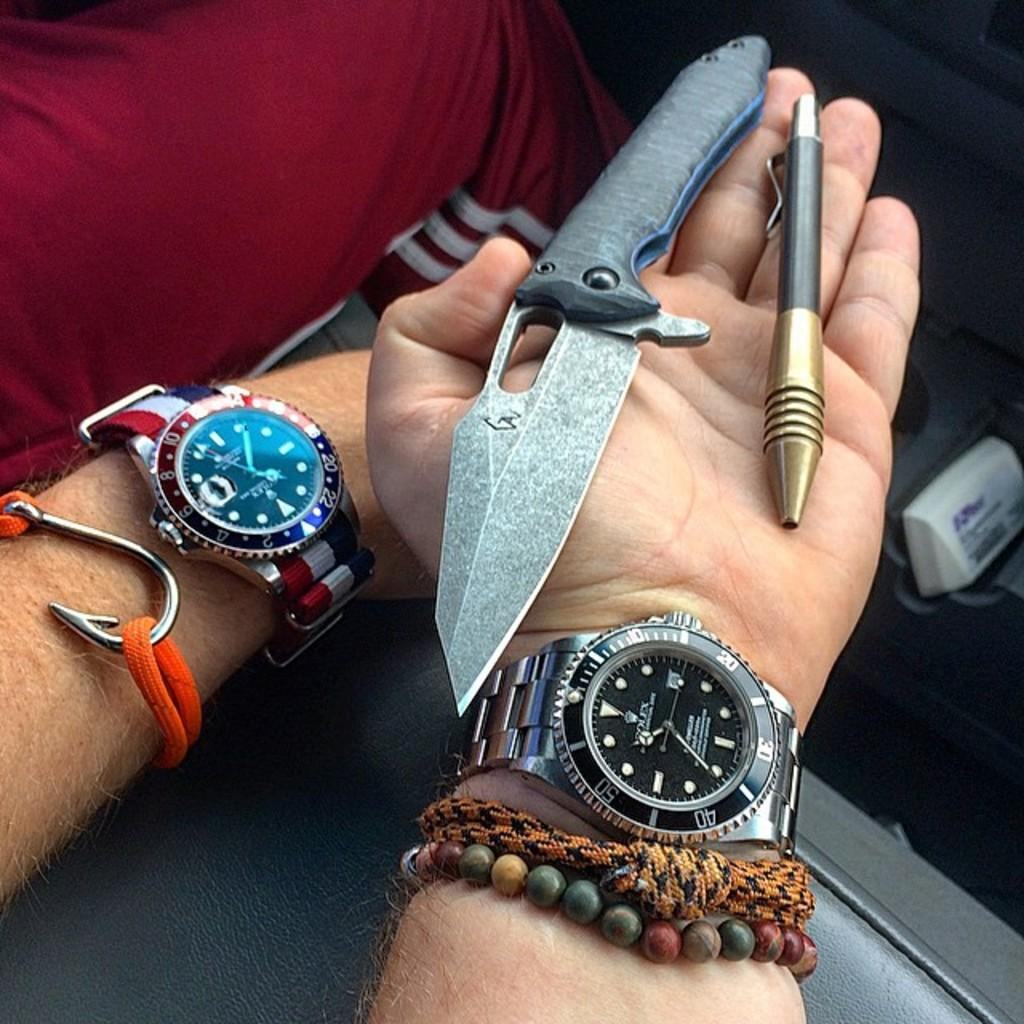<image>
Give a short and clear explanation of the subsequent image. A person with a Rolex on their wrist holding a pen and a knife in their hand. 